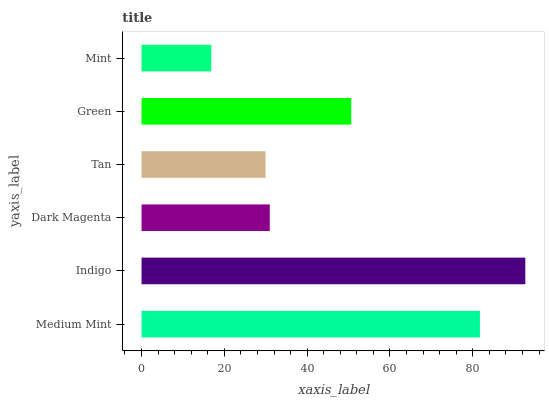Is Mint the minimum?
Answer yes or no. Yes. Is Indigo the maximum?
Answer yes or no. Yes. Is Dark Magenta the minimum?
Answer yes or no. No. Is Dark Magenta the maximum?
Answer yes or no. No. Is Indigo greater than Dark Magenta?
Answer yes or no. Yes. Is Dark Magenta less than Indigo?
Answer yes or no. Yes. Is Dark Magenta greater than Indigo?
Answer yes or no. No. Is Indigo less than Dark Magenta?
Answer yes or no. No. Is Green the high median?
Answer yes or no. Yes. Is Dark Magenta the low median?
Answer yes or no. Yes. Is Medium Mint the high median?
Answer yes or no. No. Is Indigo the low median?
Answer yes or no. No. 